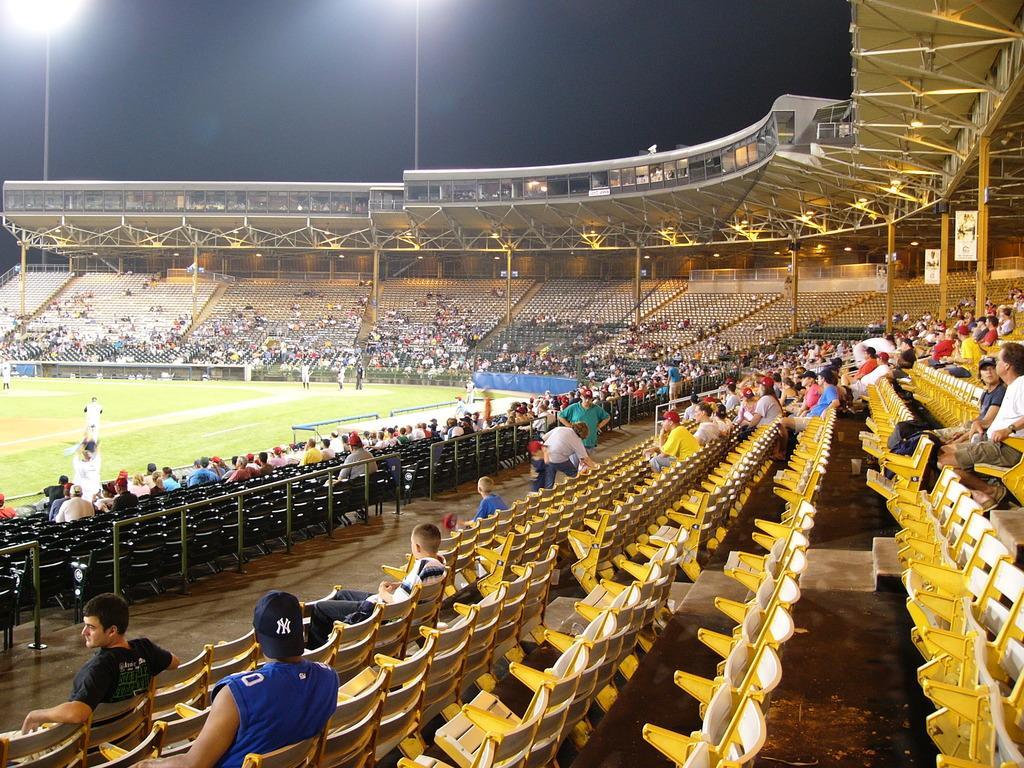Describe this image in one or two sentences. In this picture in the front there are empty chairs and in the center there are persons sitting and standing. In the background there are empty chairs and there are persons sitting and standing and in the stadium there are persons playing. On the top there are poles and there are lights and there is a shelter. 